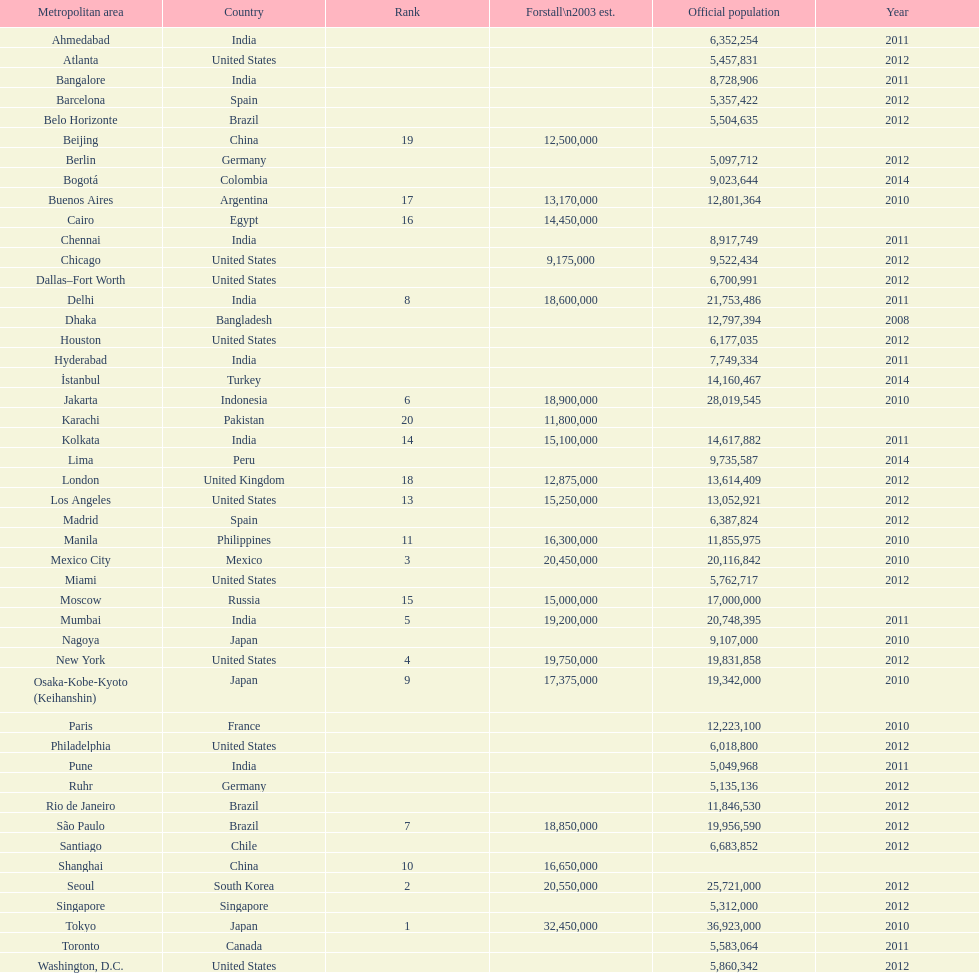Which place is referred to prior to chicago? Chennai. 